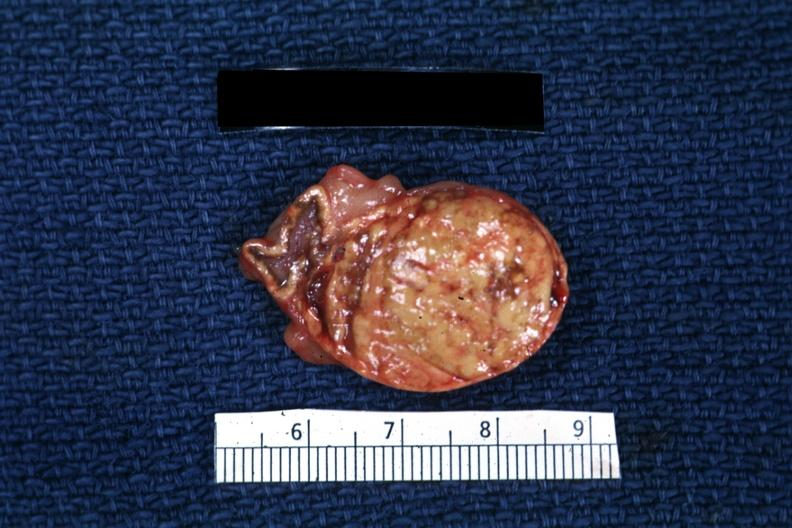s endocrine present?
Answer the question using a single word or phrase. Yes 